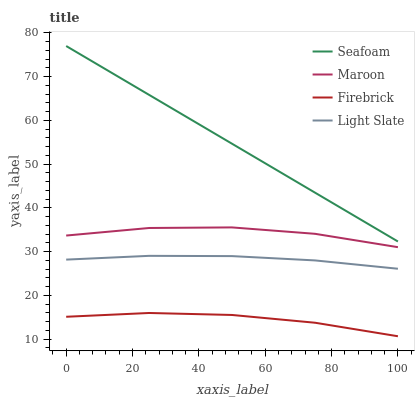Does Firebrick have the minimum area under the curve?
Answer yes or no. Yes. Does Seafoam have the maximum area under the curve?
Answer yes or no. Yes. Does Seafoam have the minimum area under the curve?
Answer yes or no. No. Does Firebrick have the maximum area under the curve?
Answer yes or no. No. Is Seafoam the smoothest?
Answer yes or no. Yes. Is Maroon the roughest?
Answer yes or no. Yes. Is Firebrick the smoothest?
Answer yes or no. No. Is Firebrick the roughest?
Answer yes or no. No. Does Firebrick have the lowest value?
Answer yes or no. Yes. Does Seafoam have the lowest value?
Answer yes or no. No. Does Seafoam have the highest value?
Answer yes or no. Yes. Does Firebrick have the highest value?
Answer yes or no. No. Is Light Slate less than Seafoam?
Answer yes or no. Yes. Is Seafoam greater than Firebrick?
Answer yes or no. Yes. Does Light Slate intersect Seafoam?
Answer yes or no. No. 